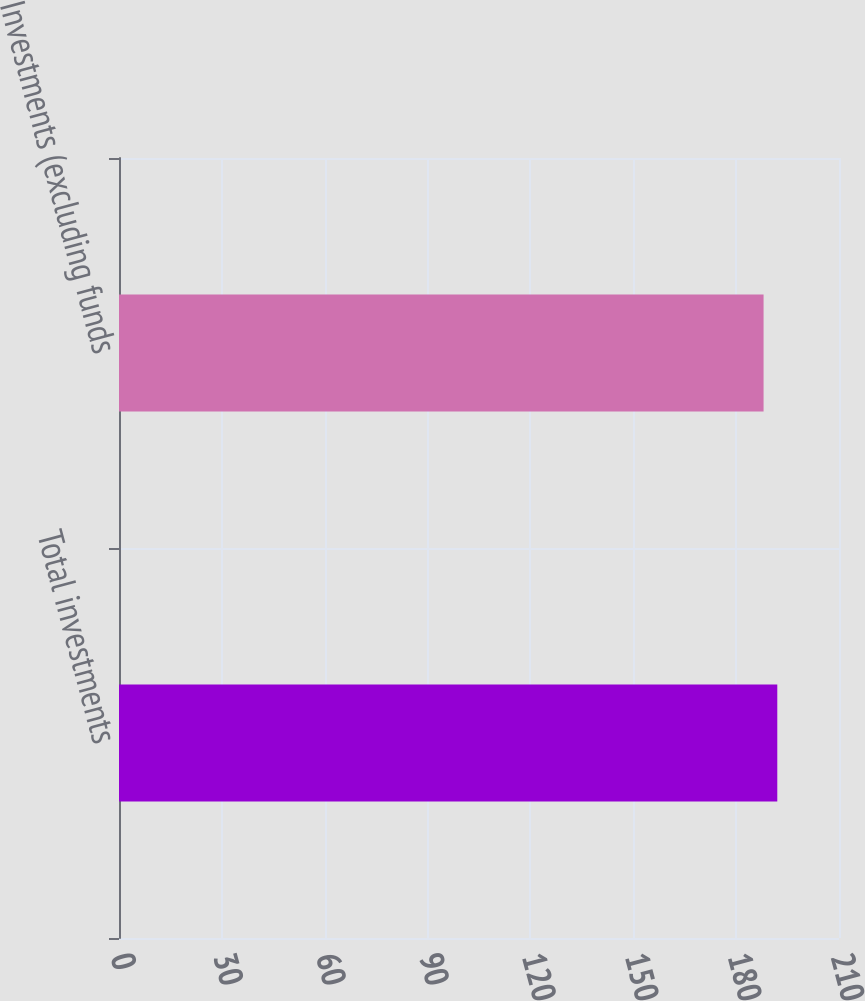<chart> <loc_0><loc_0><loc_500><loc_500><bar_chart><fcel>Total investments<fcel>Investments (excluding funds<nl><fcel>192<fcel>188<nl></chart> 